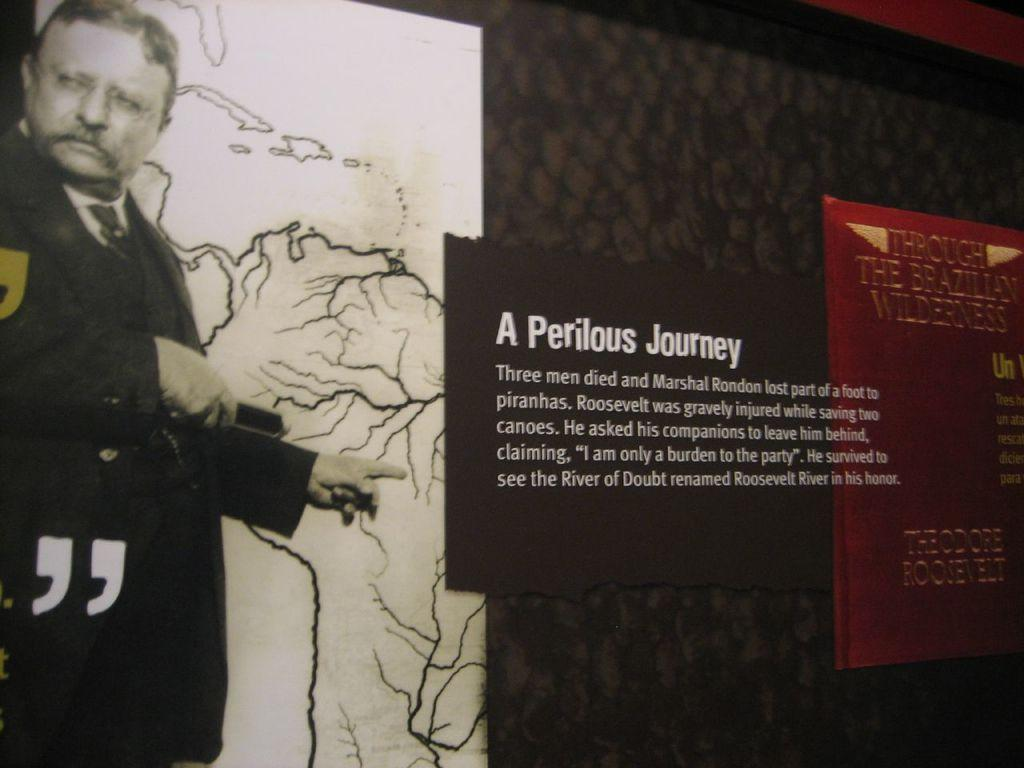Provide a one-sentence caption for the provided image. A museum wall display labeled A Perilous Journey aith a large image of Theodore Roosevelt. 